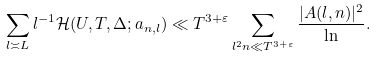Convert formula to latex. <formula><loc_0><loc_0><loc_500><loc_500>\sum _ { l \asymp L } l ^ { - 1 } \mathcal { H } ( U , T , \Delta ; a _ { n , l } ) \ll T ^ { 3 + \varepsilon } \sum _ { l ^ { 2 } n \ll T ^ { 3 + \varepsilon } } \frac { | A ( l , n ) | ^ { 2 } } { \ln } .</formula> 